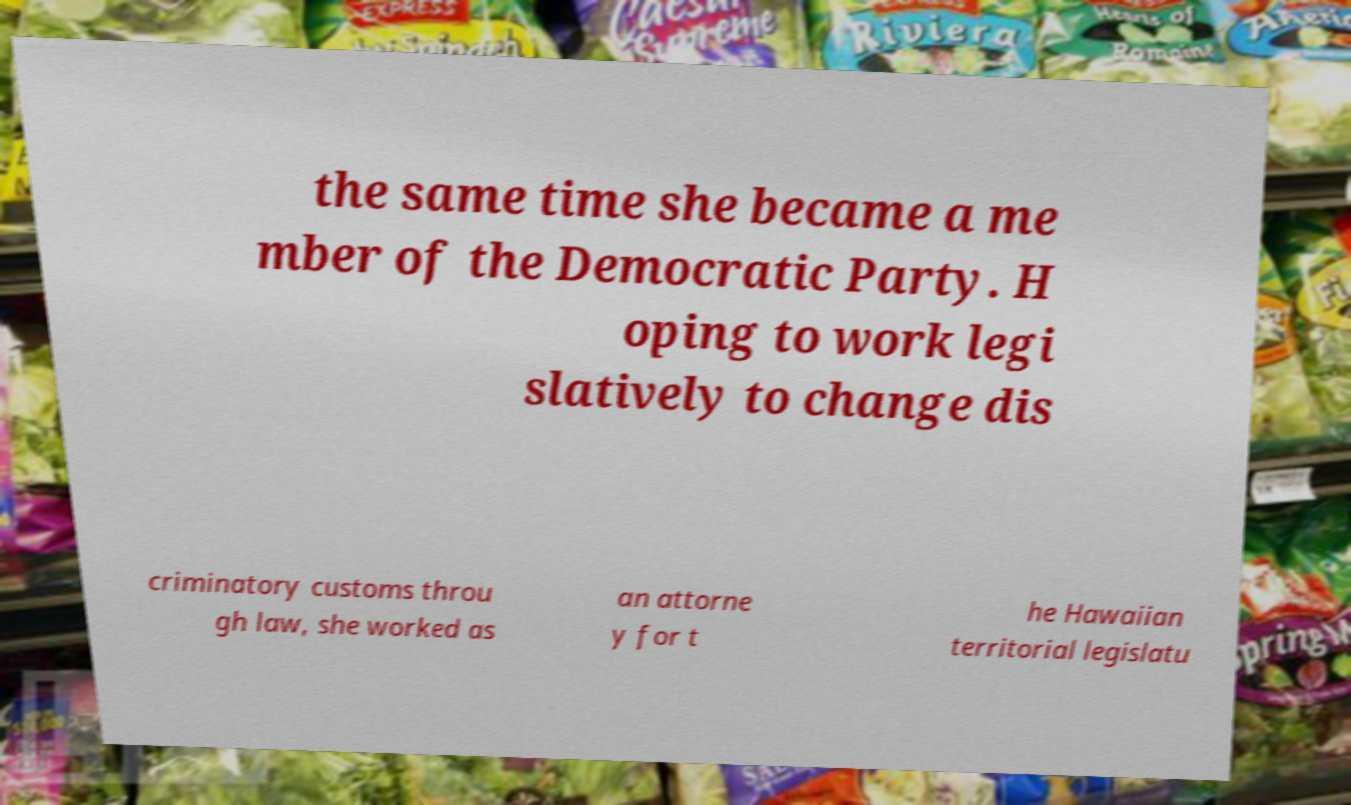Can you accurately transcribe the text from the provided image for me? the same time she became a me mber of the Democratic Party. H oping to work legi slatively to change dis criminatory customs throu gh law, she worked as an attorne y for t he Hawaiian territorial legislatu 